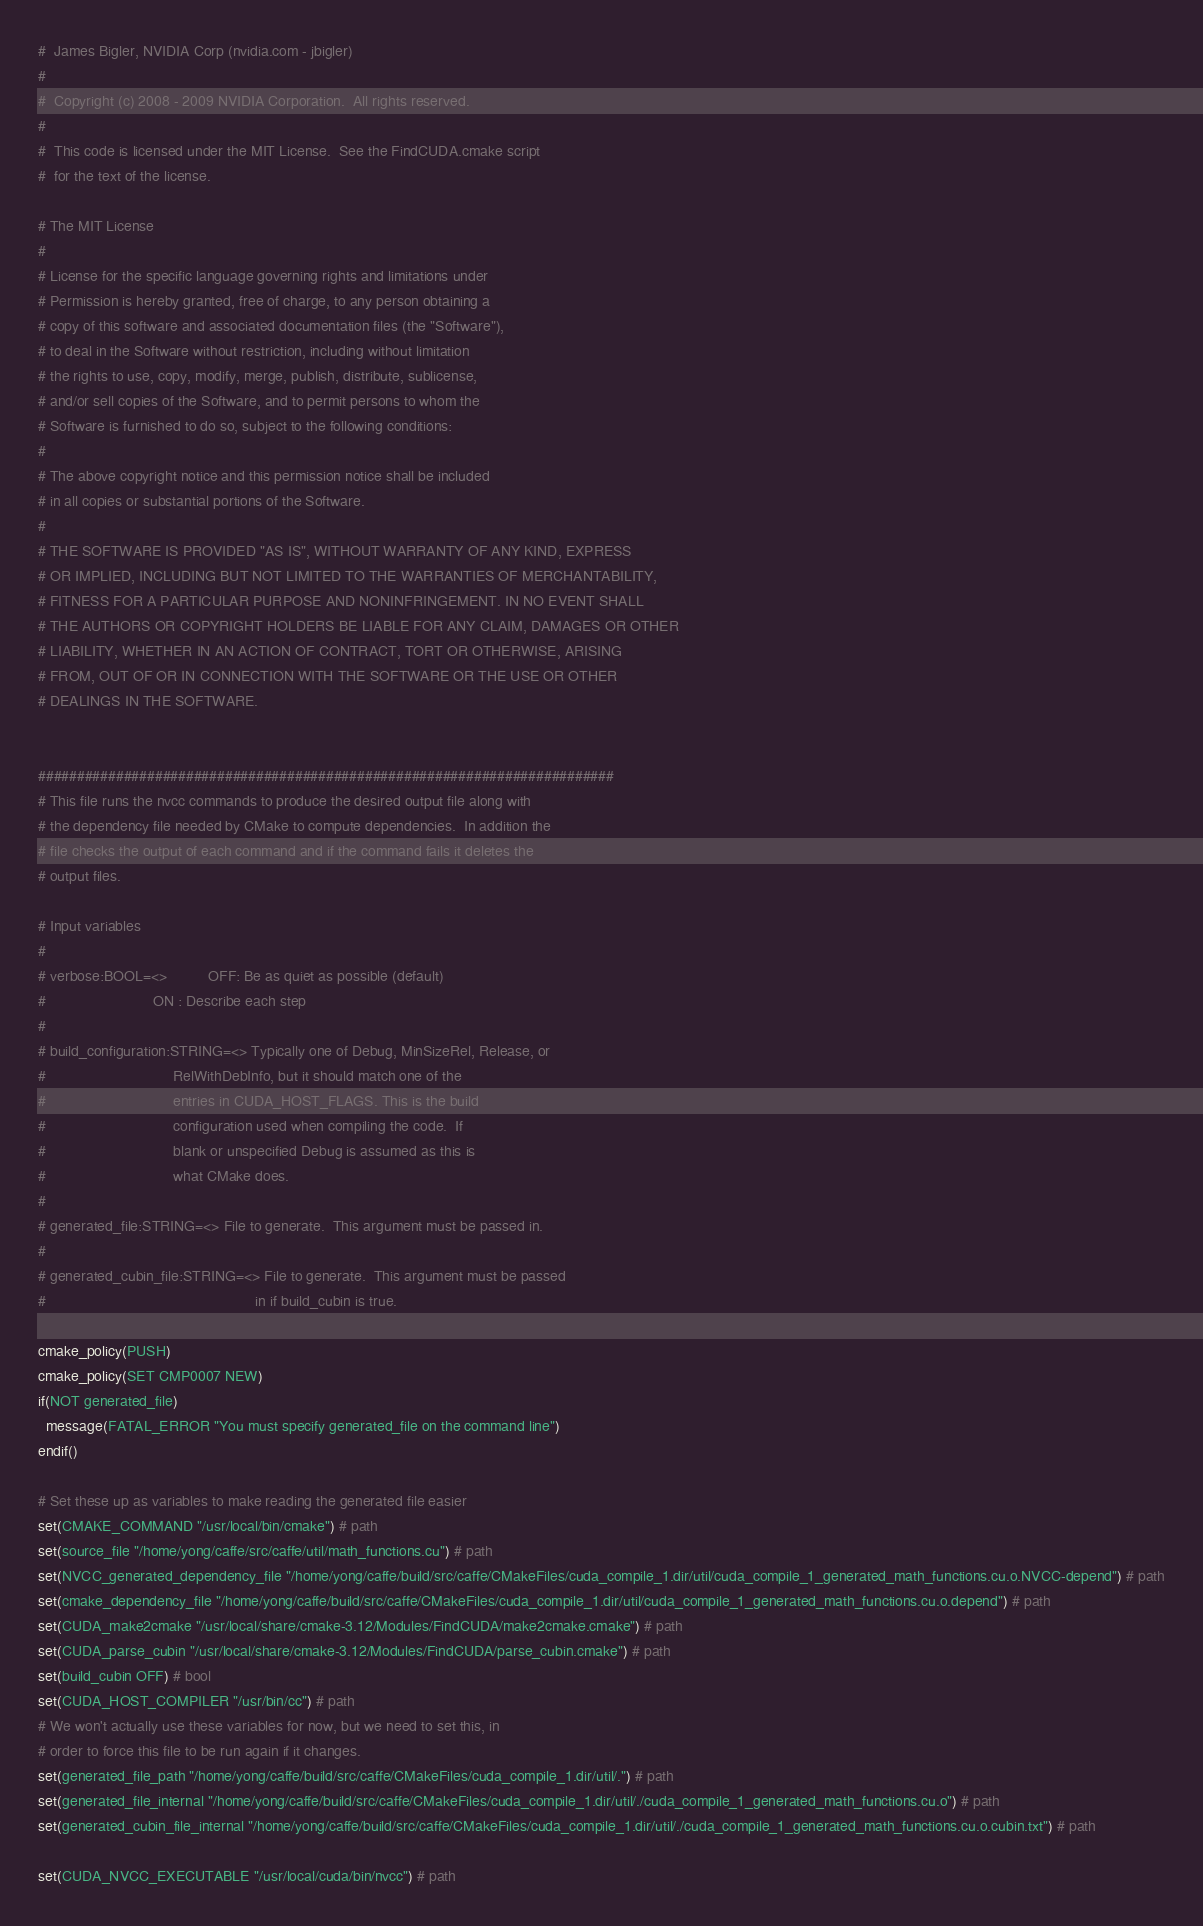Convert code to text. <code><loc_0><loc_0><loc_500><loc_500><_CMake_>#  James Bigler, NVIDIA Corp (nvidia.com - jbigler)
#
#  Copyright (c) 2008 - 2009 NVIDIA Corporation.  All rights reserved.
#
#  This code is licensed under the MIT License.  See the FindCUDA.cmake script
#  for the text of the license.

# The MIT License
#
# License for the specific language governing rights and limitations under
# Permission is hereby granted, free of charge, to any person obtaining a
# copy of this software and associated documentation files (the "Software"),
# to deal in the Software without restriction, including without limitation
# the rights to use, copy, modify, merge, publish, distribute, sublicense,
# and/or sell copies of the Software, and to permit persons to whom the
# Software is furnished to do so, subject to the following conditions:
#
# The above copyright notice and this permission notice shall be included
# in all copies or substantial portions of the Software.
#
# THE SOFTWARE IS PROVIDED "AS IS", WITHOUT WARRANTY OF ANY KIND, EXPRESS
# OR IMPLIED, INCLUDING BUT NOT LIMITED TO THE WARRANTIES OF MERCHANTABILITY,
# FITNESS FOR A PARTICULAR PURPOSE AND NONINFRINGEMENT. IN NO EVENT SHALL
# THE AUTHORS OR COPYRIGHT HOLDERS BE LIABLE FOR ANY CLAIM, DAMAGES OR OTHER
# LIABILITY, WHETHER IN AN ACTION OF CONTRACT, TORT OR OTHERWISE, ARISING
# FROM, OUT OF OR IN CONNECTION WITH THE SOFTWARE OR THE USE OR OTHER
# DEALINGS IN THE SOFTWARE.


##########################################################################
# This file runs the nvcc commands to produce the desired output file along with
# the dependency file needed by CMake to compute dependencies.  In addition the
# file checks the output of each command and if the command fails it deletes the
# output files.

# Input variables
#
# verbose:BOOL=<>          OFF: Be as quiet as possible (default)
#                          ON : Describe each step
#
# build_configuration:STRING=<> Typically one of Debug, MinSizeRel, Release, or
#                               RelWithDebInfo, but it should match one of the
#                               entries in CUDA_HOST_FLAGS. This is the build
#                               configuration used when compiling the code.  If
#                               blank or unspecified Debug is assumed as this is
#                               what CMake does.
#
# generated_file:STRING=<> File to generate.  This argument must be passed in.
#
# generated_cubin_file:STRING=<> File to generate.  This argument must be passed
#                                                   in if build_cubin is true.

cmake_policy(PUSH)
cmake_policy(SET CMP0007 NEW)
if(NOT generated_file)
  message(FATAL_ERROR "You must specify generated_file on the command line")
endif()

# Set these up as variables to make reading the generated file easier
set(CMAKE_COMMAND "/usr/local/bin/cmake") # path
set(source_file "/home/yong/caffe/src/caffe/util/math_functions.cu") # path
set(NVCC_generated_dependency_file "/home/yong/caffe/build/src/caffe/CMakeFiles/cuda_compile_1.dir/util/cuda_compile_1_generated_math_functions.cu.o.NVCC-depend") # path
set(cmake_dependency_file "/home/yong/caffe/build/src/caffe/CMakeFiles/cuda_compile_1.dir/util/cuda_compile_1_generated_math_functions.cu.o.depend") # path
set(CUDA_make2cmake "/usr/local/share/cmake-3.12/Modules/FindCUDA/make2cmake.cmake") # path
set(CUDA_parse_cubin "/usr/local/share/cmake-3.12/Modules/FindCUDA/parse_cubin.cmake") # path
set(build_cubin OFF) # bool
set(CUDA_HOST_COMPILER "/usr/bin/cc") # path
# We won't actually use these variables for now, but we need to set this, in
# order to force this file to be run again if it changes.
set(generated_file_path "/home/yong/caffe/build/src/caffe/CMakeFiles/cuda_compile_1.dir/util/.") # path
set(generated_file_internal "/home/yong/caffe/build/src/caffe/CMakeFiles/cuda_compile_1.dir/util/./cuda_compile_1_generated_math_functions.cu.o") # path
set(generated_cubin_file_internal "/home/yong/caffe/build/src/caffe/CMakeFiles/cuda_compile_1.dir/util/./cuda_compile_1_generated_math_functions.cu.o.cubin.txt") # path

set(CUDA_NVCC_EXECUTABLE "/usr/local/cuda/bin/nvcc") # path</code> 